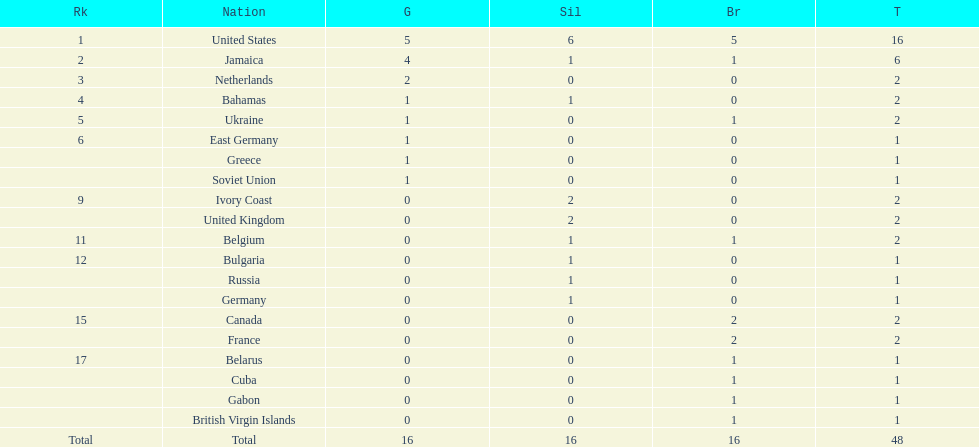How many nations received more medals than canada? 2. 